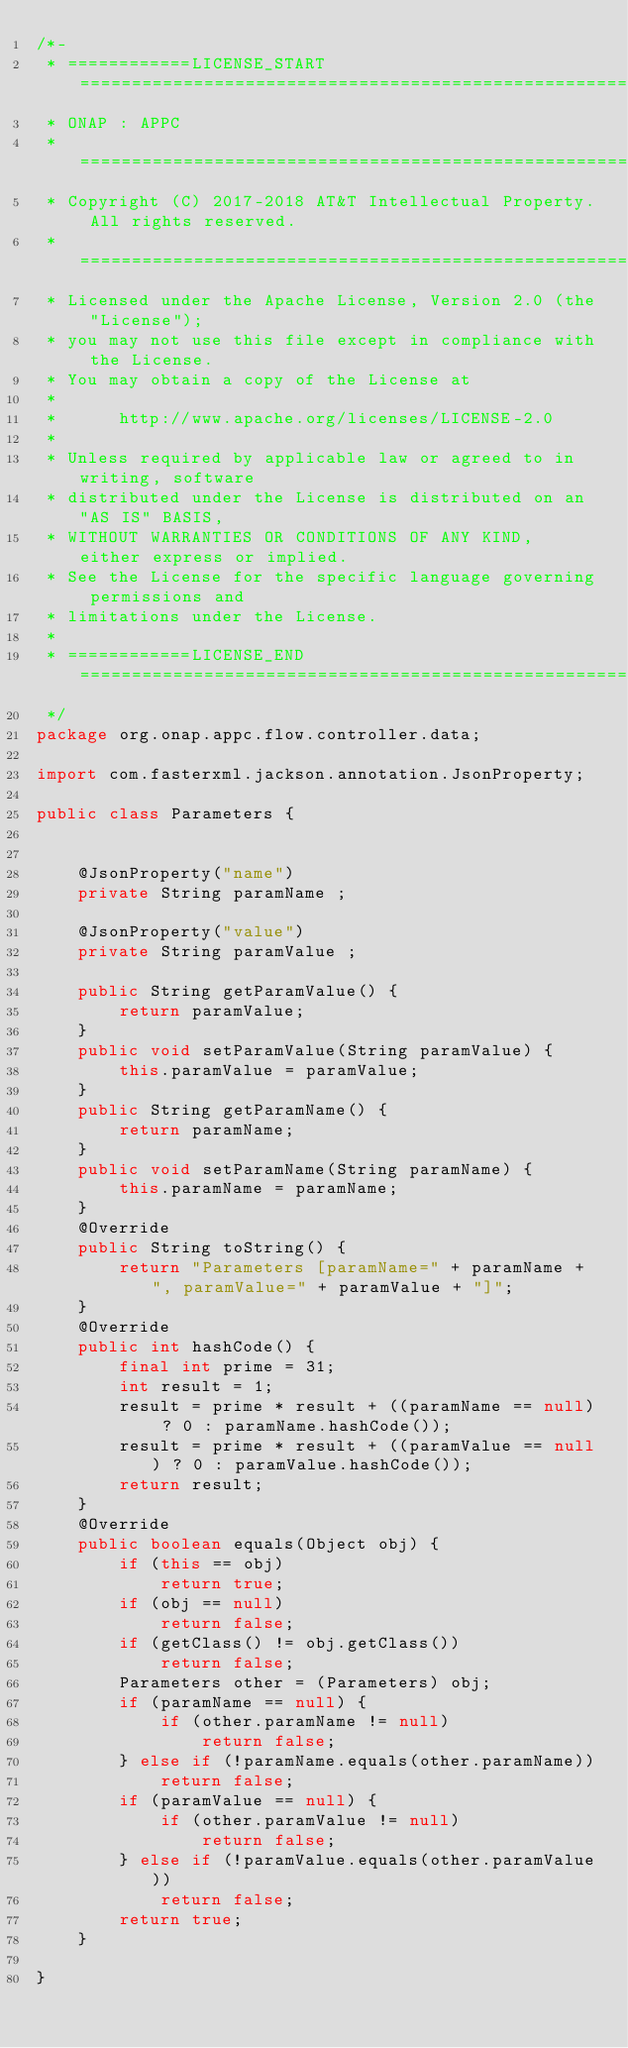Convert code to text. <code><loc_0><loc_0><loc_500><loc_500><_Java_>/*-
 * ============LICENSE_START=======================================================
 * ONAP : APPC
 * ================================================================================
 * Copyright (C) 2017-2018 AT&T Intellectual Property. All rights reserved.
 * =============================================================================
 * Licensed under the Apache License, Version 2.0 (the "License");
 * you may not use this file except in compliance with the License.
 * You may obtain a copy of the License at
 *
 *      http://www.apache.org/licenses/LICENSE-2.0
 *
 * Unless required by applicable law or agreed to in writing, software
 * distributed under the License is distributed on an "AS IS" BASIS,
 * WITHOUT WARRANTIES OR CONDITIONS OF ANY KIND, either express or implied.
 * See the License for the specific language governing permissions and
 * limitations under the License.
 *
 * ============LICENSE_END=========================================================
 */
package org.onap.appc.flow.controller.data;

import com.fasterxml.jackson.annotation.JsonProperty;

public class Parameters {


    @JsonProperty("name")
    private String paramName ;

    @JsonProperty("value")
    private String paramValue ;

    public String getParamValue() {
        return paramValue;
    }
    public void setParamValue(String paramValue) {
        this.paramValue = paramValue;
    }
    public String getParamName() {
        return paramName;
    }
    public void setParamName(String paramName) {
        this.paramName = paramName;
    }
    @Override
    public String toString() {
        return "Parameters [paramName=" + paramName + ", paramValue=" + paramValue + "]";
    }
    @Override
    public int hashCode() {
        final int prime = 31;
        int result = 1;
        result = prime * result + ((paramName == null) ? 0 : paramName.hashCode());
        result = prime * result + ((paramValue == null) ? 0 : paramValue.hashCode());
        return result;
    }
    @Override
    public boolean equals(Object obj) {
        if (this == obj)
            return true;
        if (obj == null)
            return false;
        if (getClass() != obj.getClass())
            return false;
        Parameters other = (Parameters) obj;
        if (paramName == null) {
            if (other.paramName != null)
                return false;
        } else if (!paramName.equals(other.paramName))
            return false;
        if (paramValue == null) {
            if (other.paramValue != null)
                return false;
        } else if (!paramValue.equals(other.paramValue))
            return false;
        return true;
    }

}
</code> 